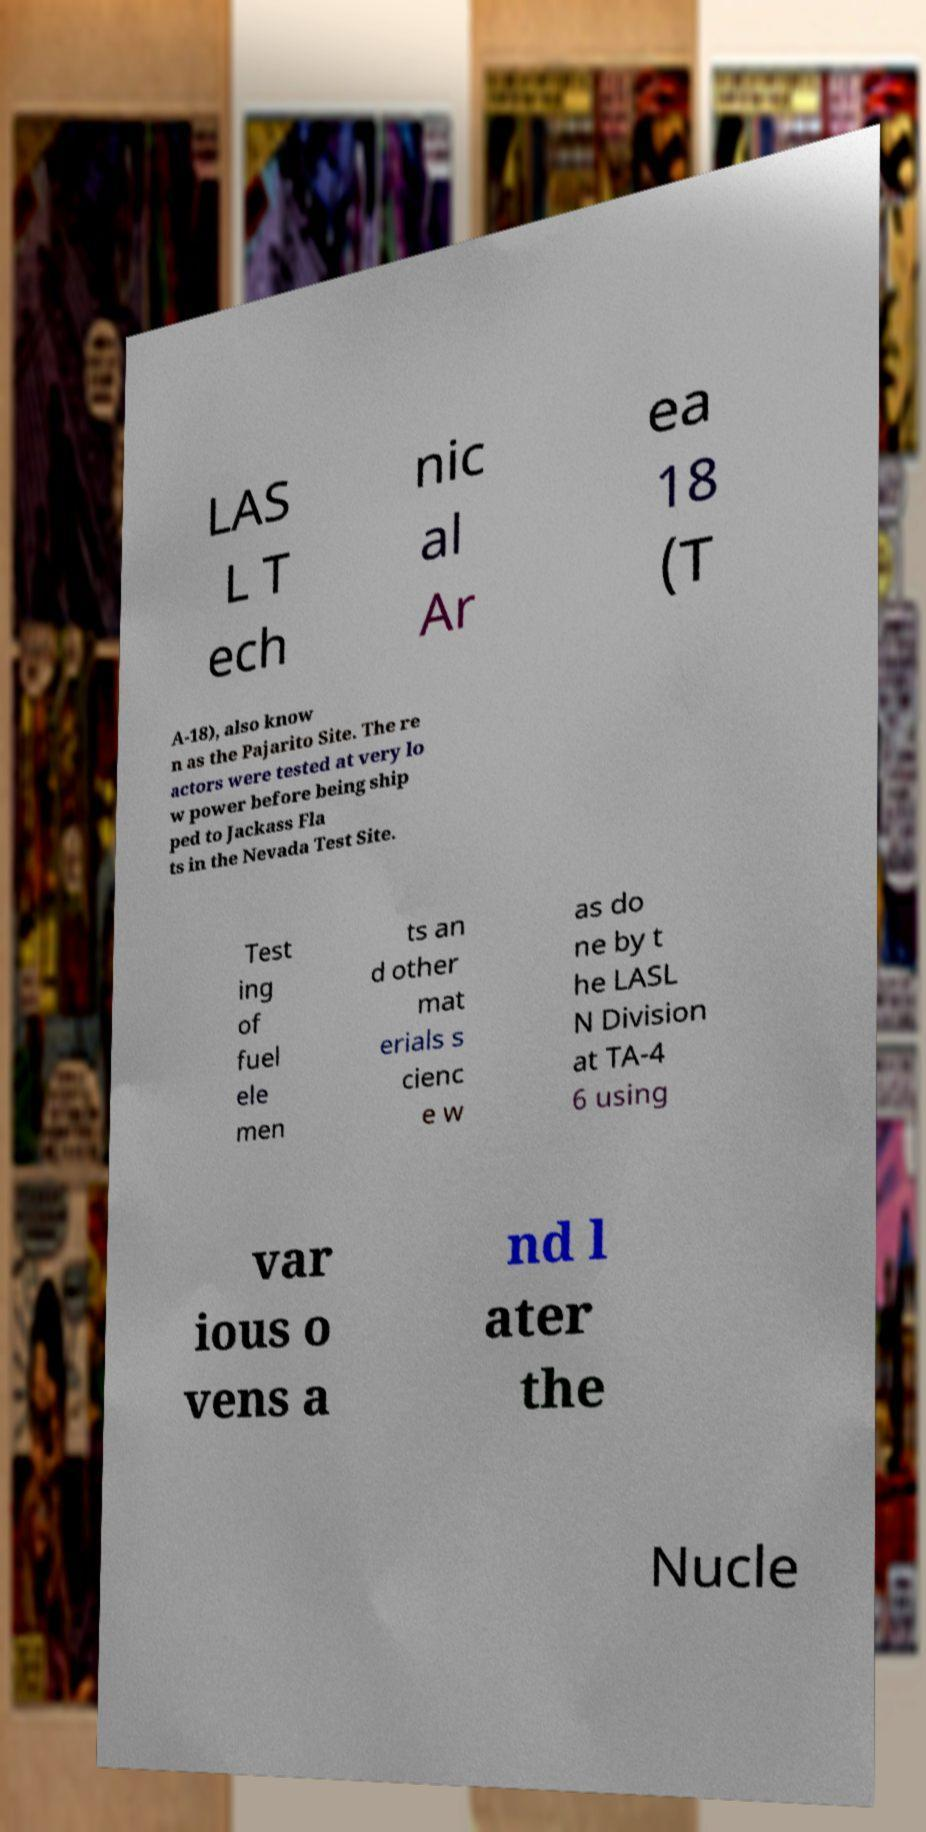There's text embedded in this image that I need extracted. Can you transcribe it verbatim? LAS L T ech nic al Ar ea 18 (T A-18), also know n as the Pajarito Site. The re actors were tested at very lo w power before being ship ped to Jackass Fla ts in the Nevada Test Site. Test ing of fuel ele men ts an d other mat erials s cienc e w as do ne by t he LASL N Division at TA-4 6 using var ious o vens a nd l ater the Nucle 